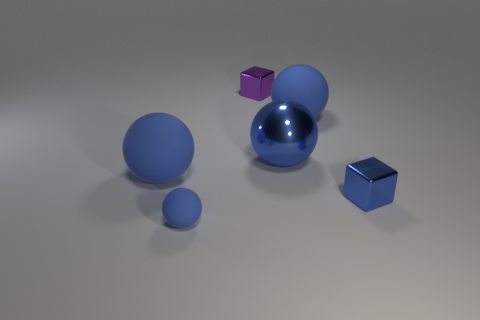Subtract 2 balls. How many balls are left? 2 Subtract all shiny balls. How many balls are left? 3 Subtract all green spheres. Subtract all brown cylinders. How many spheres are left? 4 Add 3 tiny cubes. How many objects exist? 9 Subtract all spheres. How many objects are left? 2 Subtract all tiny objects. Subtract all blue matte things. How many objects are left? 0 Add 1 big blue things. How many big blue things are left? 4 Add 6 big metallic balls. How many big metallic balls exist? 7 Subtract 0 brown blocks. How many objects are left? 6 